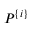<formula> <loc_0><loc_0><loc_500><loc_500>P ^ { \{ i \} }</formula> 